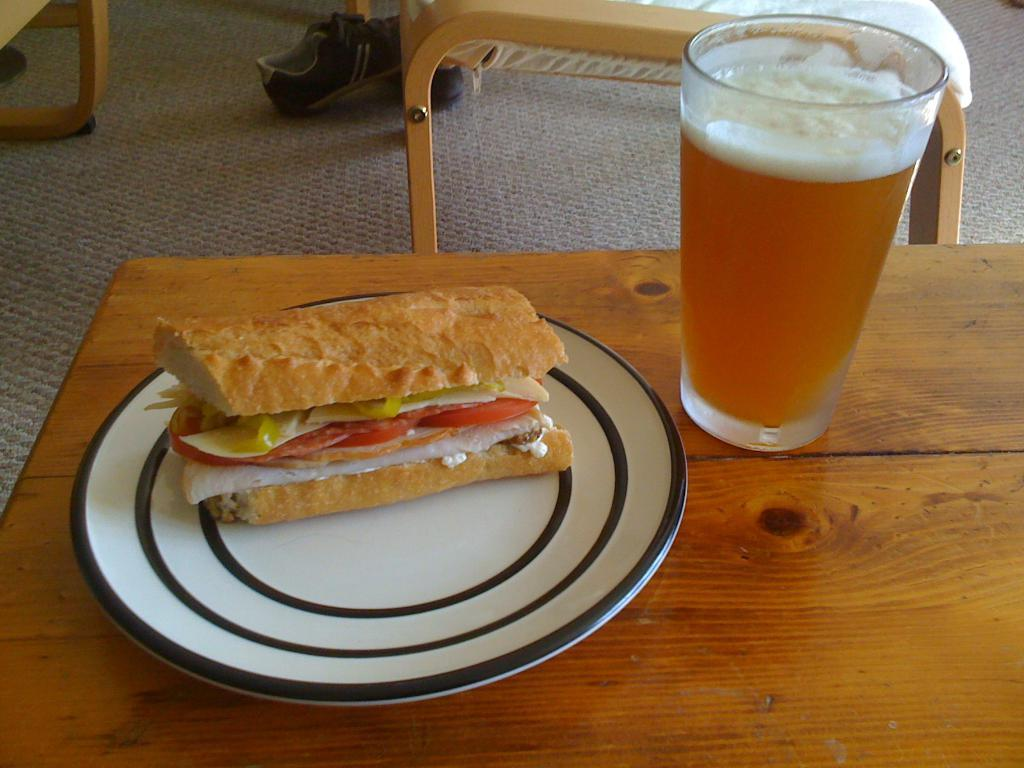What is on the plate in the image? There is a food item on a plate in the image. What beverage is visible in the image? There is a glass of wine on the table in the image. What type of furniture is in the image? There is a chair in the image. What type of footwear is on the carpet in the image? There is a pair of shoes on the carpet in the image. How many ants are crawling on the food item in the image? There are no ants present in the image; it only shows a food item on a plate. What type of offer is being made in the image? There is no offer being made in the image; it only shows a food item, a glass of wine, a chair, and a pair of shoes. 